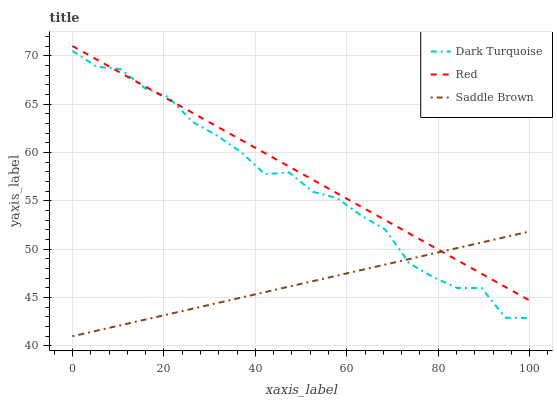Does Saddle Brown have the minimum area under the curve?
Answer yes or no. Yes. Does Red have the maximum area under the curve?
Answer yes or no. Yes. Does Red have the minimum area under the curve?
Answer yes or no. No. Does Saddle Brown have the maximum area under the curve?
Answer yes or no. No. Is Saddle Brown the smoothest?
Answer yes or no. Yes. Is Dark Turquoise the roughest?
Answer yes or no. Yes. Is Red the smoothest?
Answer yes or no. No. Is Red the roughest?
Answer yes or no. No. Does Saddle Brown have the lowest value?
Answer yes or no. Yes. Does Red have the lowest value?
Answer yes or no. No. Does Red have the highest value?
Answer yes or no. Yes. Does Saddle Brown have the highest value?
Answer yes or no. No. Does Saddle Brown intersect Red?
Answer yes or no. Yes. Is Saddle Brown less than Red?
Answer yes or no. No. Is Saddle Brown greater than Red?
Answer yes or no. No. 